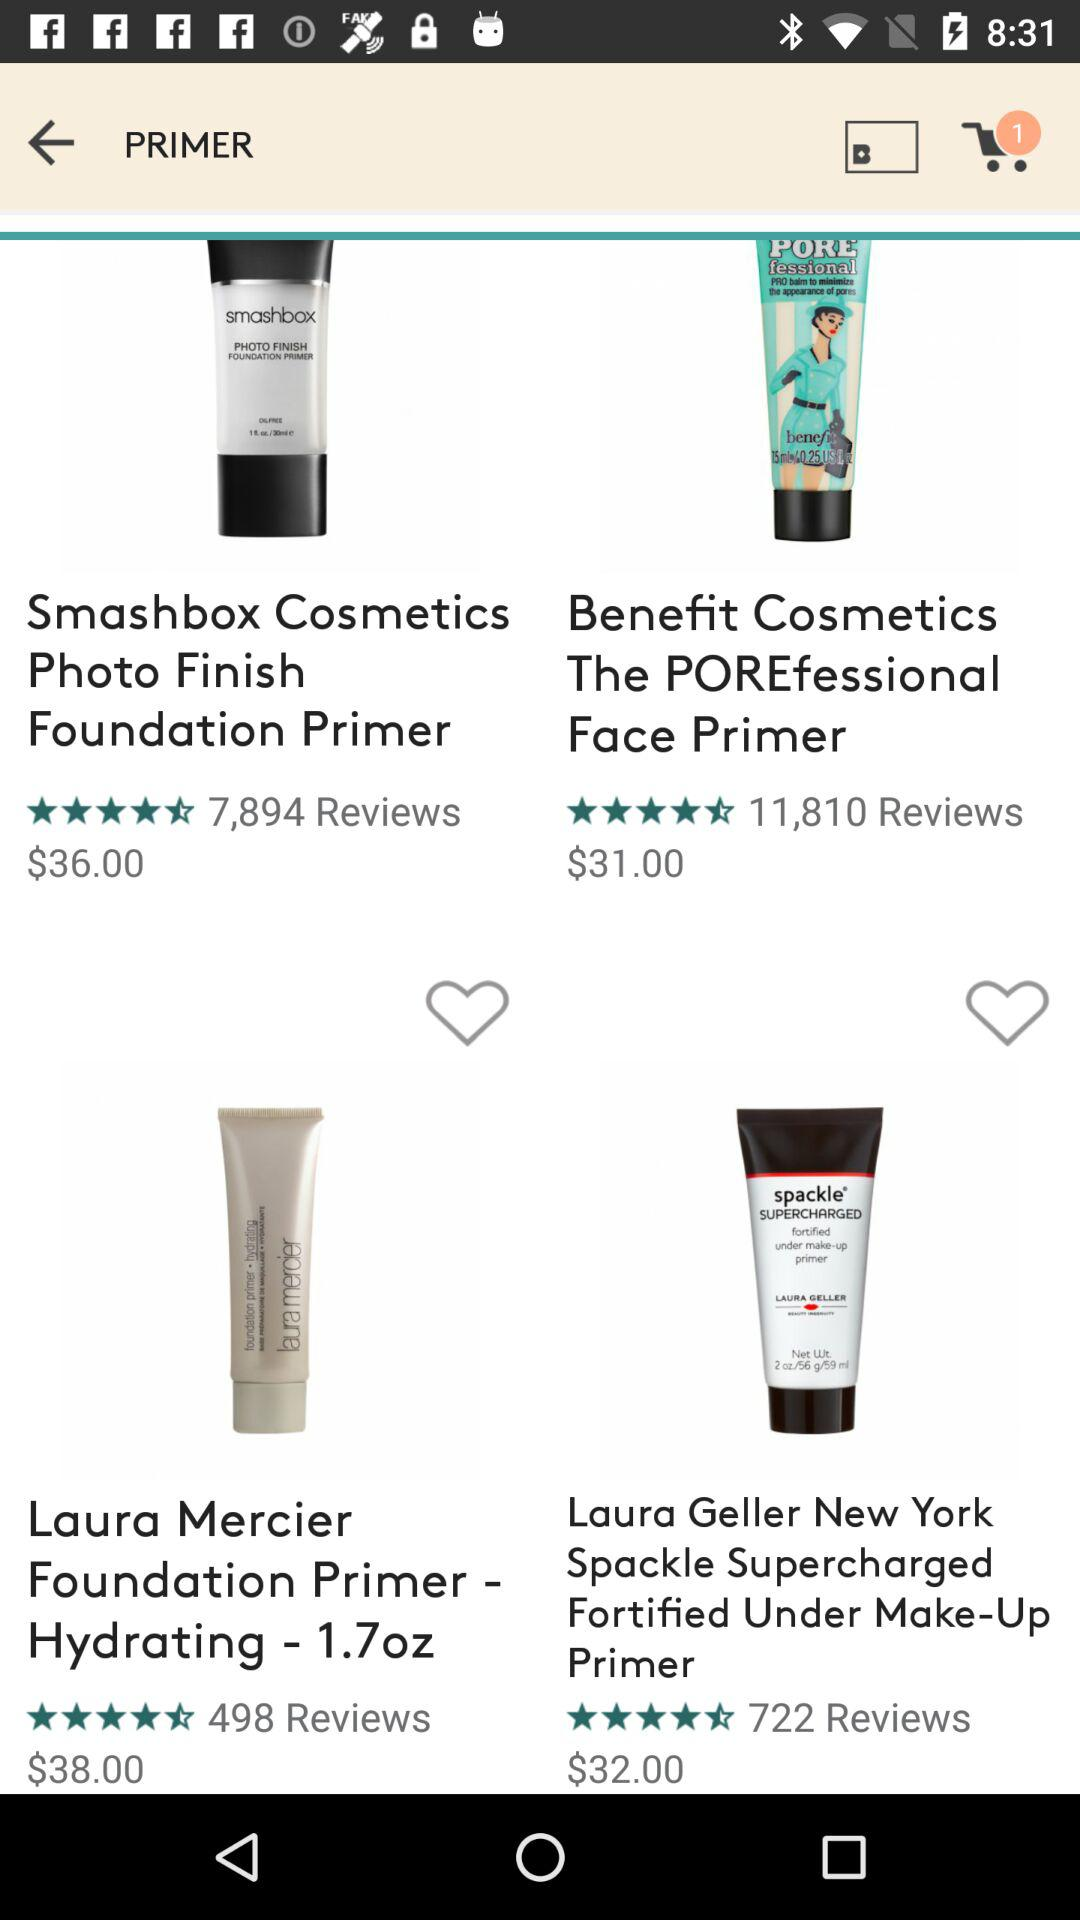How many items are in the cart? There is 1 item in the cart. 